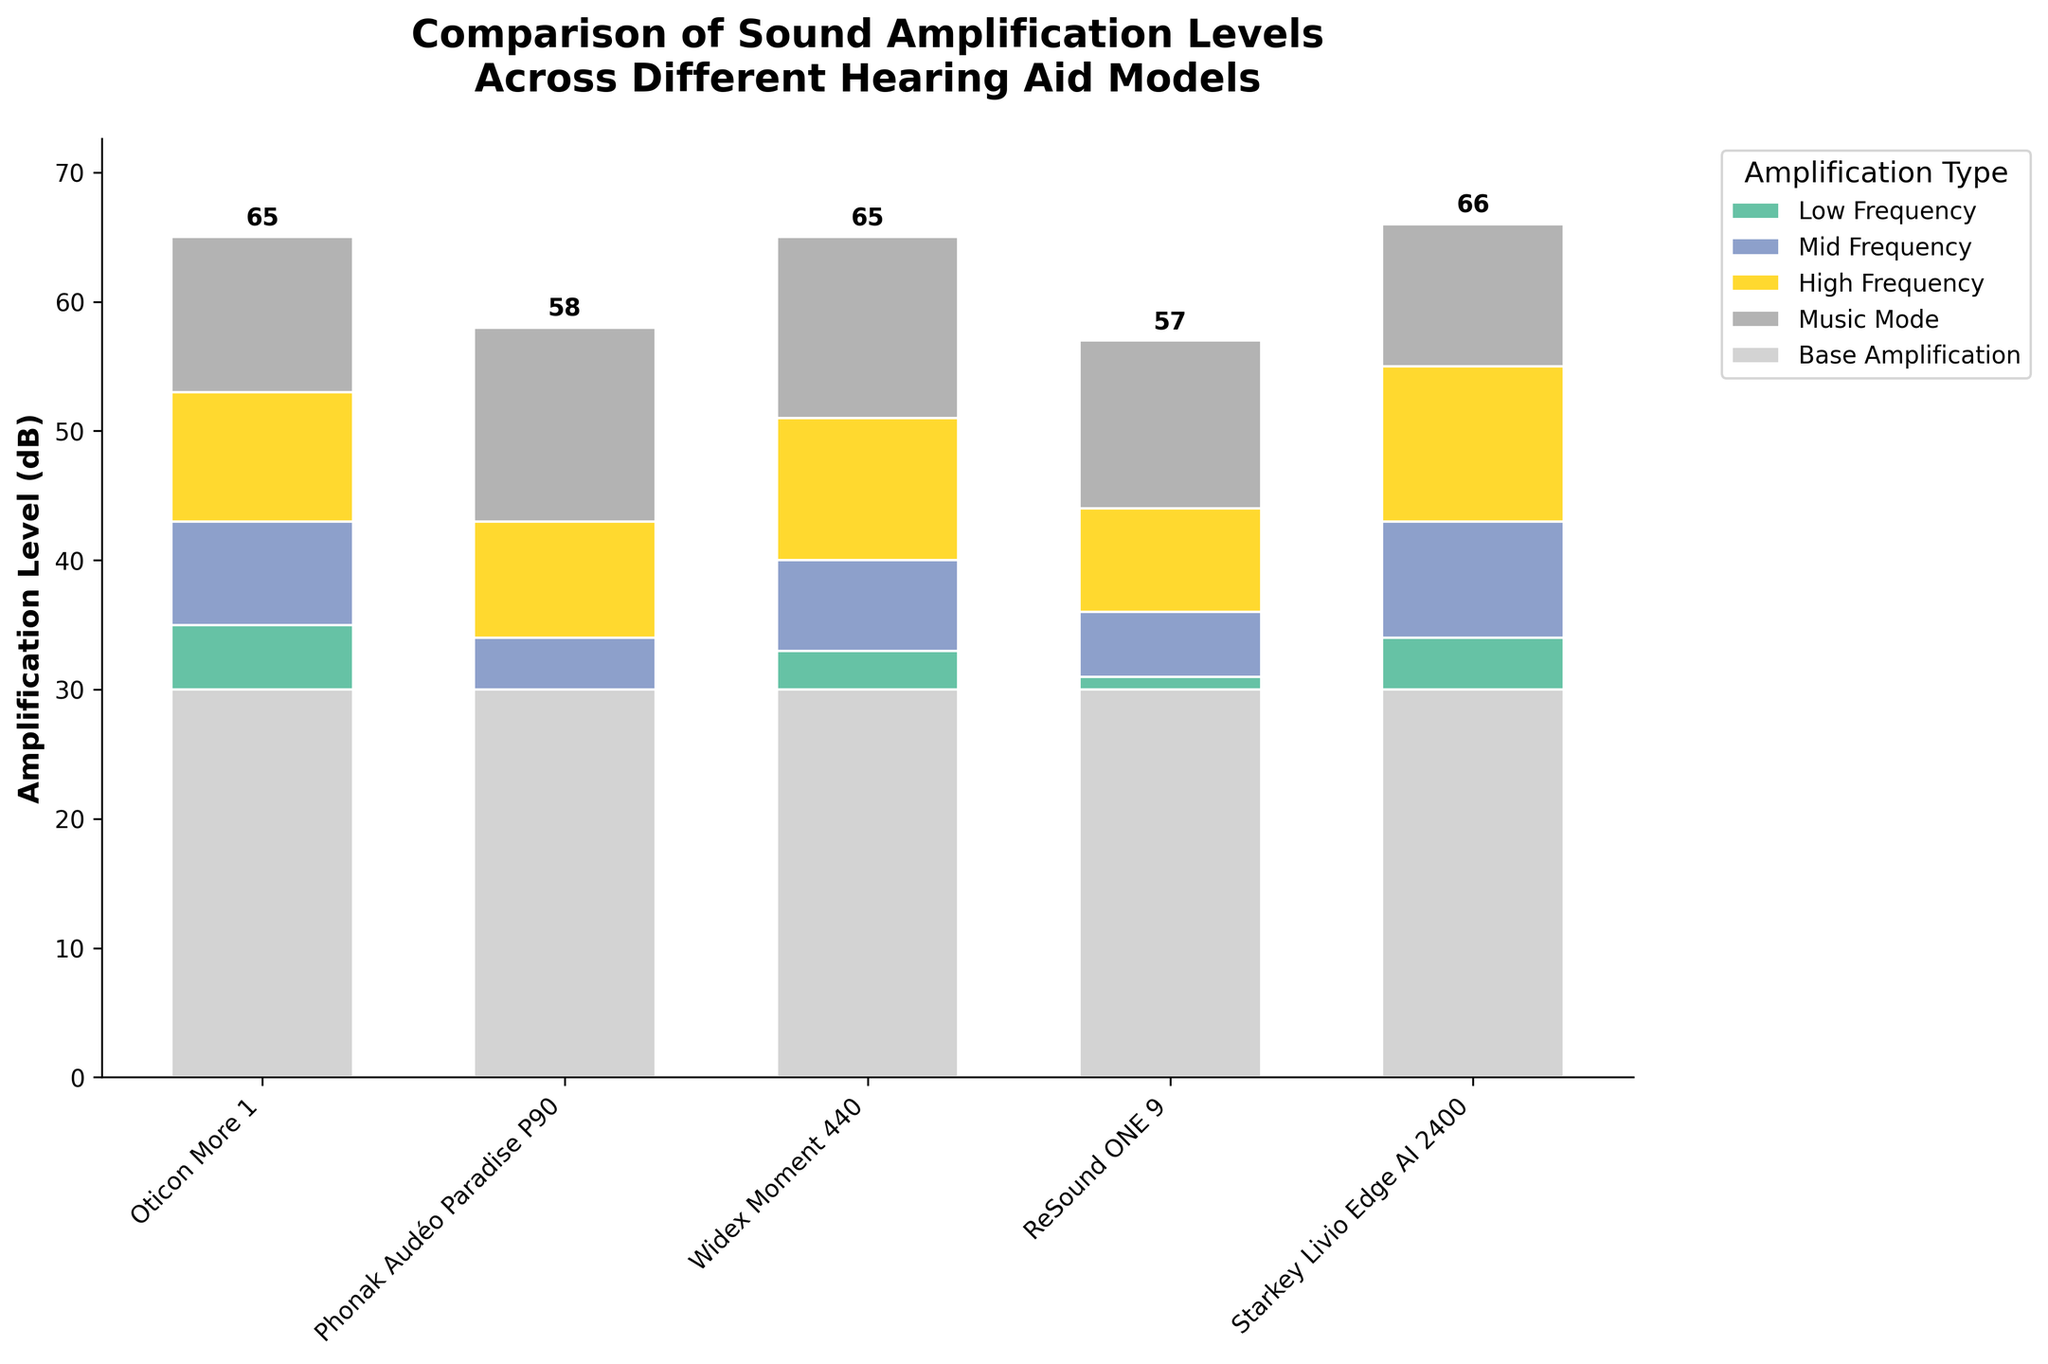what is the title of the figure? The title of the figure is displayed at the top and reads "Comparison of Sound Amplification Levels Across Different Hearing Aid Models".
Answer: Comparison of Sound Amplification Levels Across Different Hearing Aid Models How many hearing aid models are compared in the figure? By counting the number of distinct category labels on the x-axis, we can identify that there are 5 hearing aid models compared in the figure.
Answer: 5 Which model has the highest total amplification level in Music Mode? To find the model with the highest total amplification level in Music Mode, look at the heights of the final segment of each bar, which represents the Music Mode amplification. The Phonak Audéo Paradise P90 model has the highest segment in the Music Mode.
Answer: Phonak Audéo Paradise P90 What is the total amplification level for the Widex Moment 440 model? To find the total amplification for the Widex Moment 440 model, sum the base amplification (30) and the increments in Low Frequency (3), Mid Frequency (7), High Frequency (11), and Music Mode (14). The total is 30 + 3 + 7 + 11 + 14 = 65 dB.
Answer: 65 dB Which amplification type shows the largest increase across any model and what is the model? To find the largest increase, look through the heights of individual segments labeled by their amplification type in each model. The Med Frequency amplification for Starkey Livio Edge AI 2400 shows the largest increase, which is 9 dB.
Answer: Mid Frequency, Starkey Livio Edge AI 2400 If we remove the Music Mode amplification, which hearing aid model would then have the highest total amplification? Sum the amplifications excluding the Music Mode: For Oticon More 1: 30 + 5 + 8 + 10 = 53 dB; Phonak Audéo Paradise P90: 30 + (-2) + 6 + 9 = 43 dB; Widex Moment 440: 30 + 3 + 7 + 11 = 51 dB; ReSound ONE 9: 30 + 1 + 5 + 8 = 44 dB; Starkey Livio Edge AI 2400: 30 + 4 + 9 + 12 = 55 dB. The Starkey Livio Edge AI 2400 model would have the highest total amplification without Music Mode.
Answer: Starkey Livio Edge AI 2400 How much amplification does ReSound ONE 9 add through all the frequency ranges? To find the total amplification added through all frequencies, sum the increments for Low Frequency (1), Mid Frequency (5), and High Frequency (8). The total amplification added is 1 + 5 + 8 = 14 dB.
Answer: 14 dB Which hearing aid model has the smallest increase in Low Frequency amplification? By looking at the segments of the bars labeled "Low Frequency", the Phonak Audéo Paradise P90 has the smallest increase, which is -2 dB.
Answer: Phonak Audéo Paradise P90 What's the average Music Mode amplification across all the models? To find the average, sum the Music Mode amplifications for all models and divide by the number of models. (12 + 15 + 14 + 13 + 11) / 5 = 65 / 5 = 13 dB.
Answer: 13 dB 